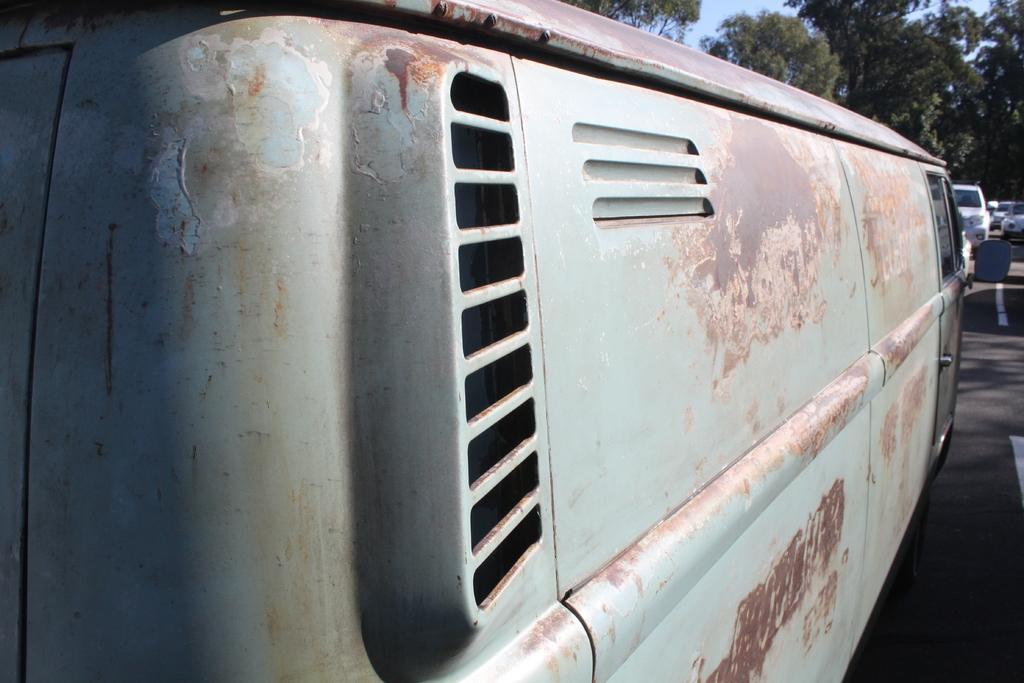Please provide a concise description of this image. In this image we can see the vehicles, trees, sky and also the road. 